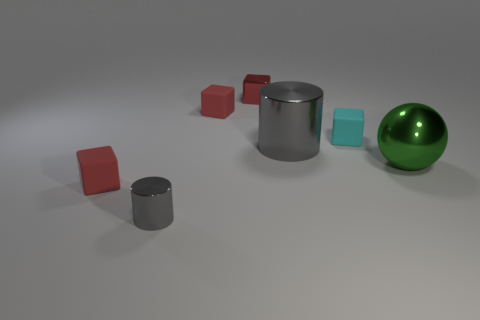Subtract all brown spheres. How many red cubes are left? 3 Subtract all metallic blocks. How many blocks are left? 3 Subtract all cyan cubes. How many cubes are left? 3 Subtract all yellow cubes. Subtract all gray balls. How many cubes are left? 4 Add 3 large green shiny objects. How many objects exist? 10 Subtract 0 blue cubes. How many objects are left? 7 Subtract all balls. How many objects are left? 6 Subtract all big gray metal cylinders. Subtract all cubes. How many objects are left? 2 Add 6 green balls. How many green balls are left? 7 Add 7 green metallic objects. How many green metallic objects exist? 8 